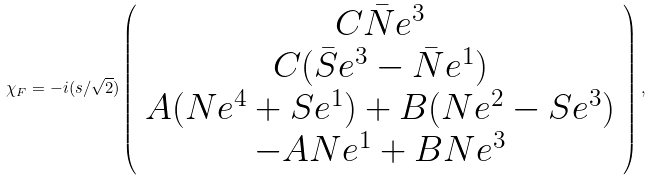Convert formula to latex. <formula><loc_0><loc_0><loc_500><loc_500>\chi _ { F } = - i ( s / \sqrt { 2 } ) \left ( \begin{array} { c } C \bar { N } e ^ { 3 } \\ C ( \bar { S } e ^ { 3 } - \bar { N } e ^ { 1 } ) \\ A ( N e ^ { 4 } + S e ^ { 1 } ) + B ( N e ^ { 2 } - S e ^ { 3 } ) \\ - A N e ^ { 1 } + B N e ^ { 3 } \end{array} \right ) ,</formula> 